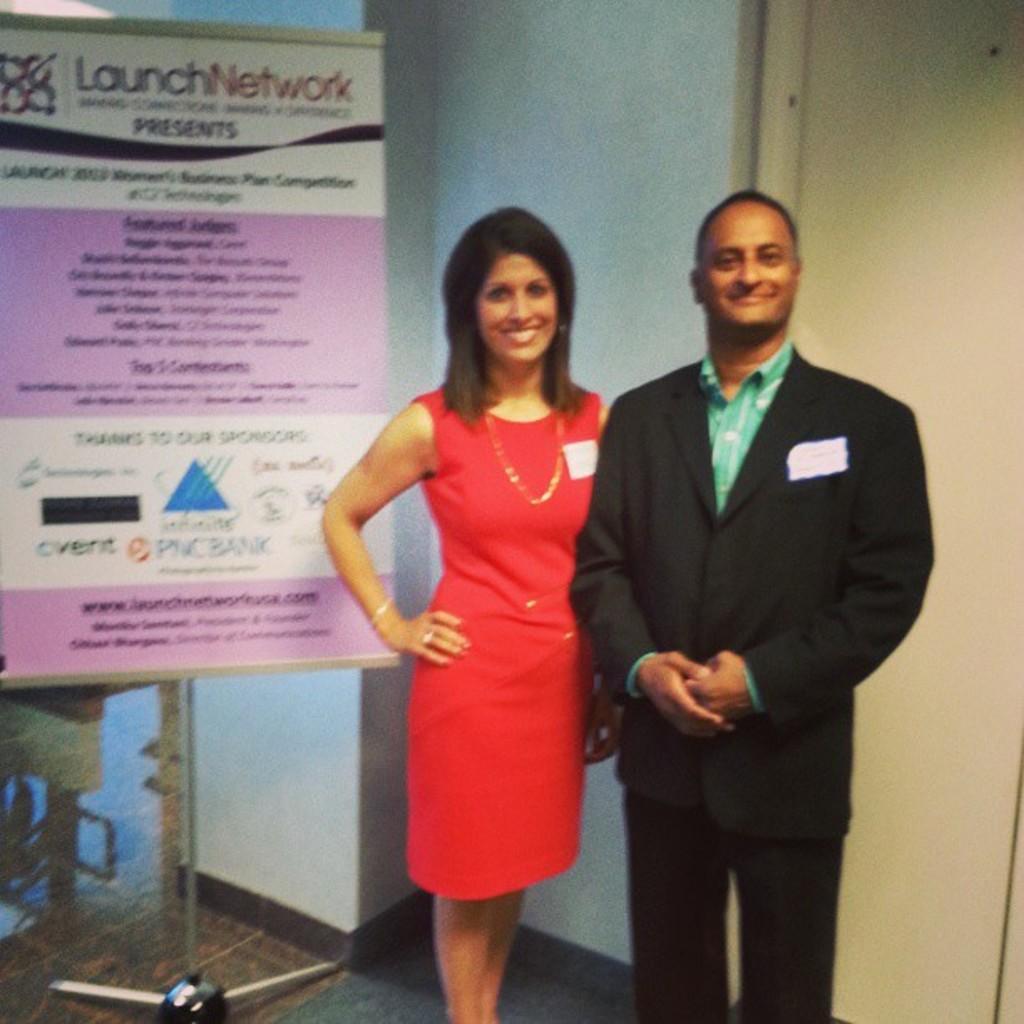Can you describe this image briefly? There are two members standing here. The left side one is woman and the right side one is a man. The woman is wearing a red dress and the man is wearing a suit with a badges. In the left there is a flex to the stand. In the background we can observe a wall. Both the man and woman are smiling. 